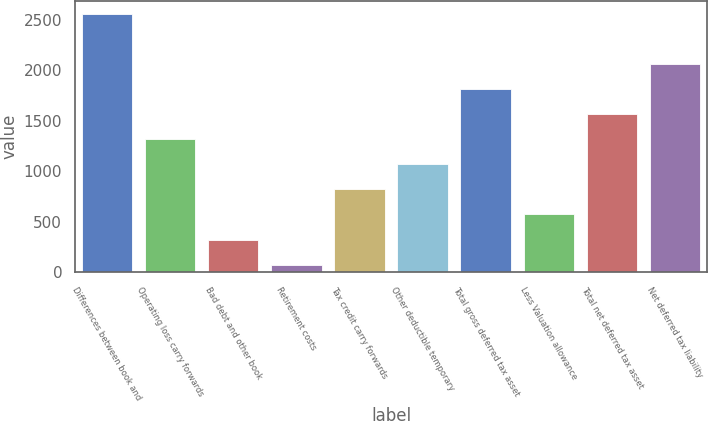<chart> <loc_0><loc_0><loc_500><loc_500><bar_chart><fcel>Differences between book and<fcel>Operating loss carry forwards<fcel>Bad debt and other book<fcel>Retirement costs<fcel>Tax credit carry forwards<fcel>Other deductible temporary<fcel>Total gross deferred tax asset<fcel>Less Valuation allowance<fcel>Total net deferred tax asset<fcel>Net deferred tax liability<nl><fcel>2562<fcel>1318.5<fcel>323.7<fcel>75<fcel>821.1<fcel>1069.8<fcel>1815.9<fcel>572.4<fcel>1567.2<fcel>2064.6<nl></chart> 